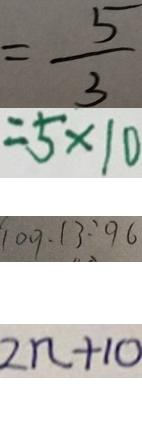<formula> <loc_0><loc_0><loc_500><loc_500>= \frac { 5 } { 3 } 
 = 5 \times 1 0 
 1 0 9 . 1 3 : 9 6 
 2 n + 1 0</formula> 